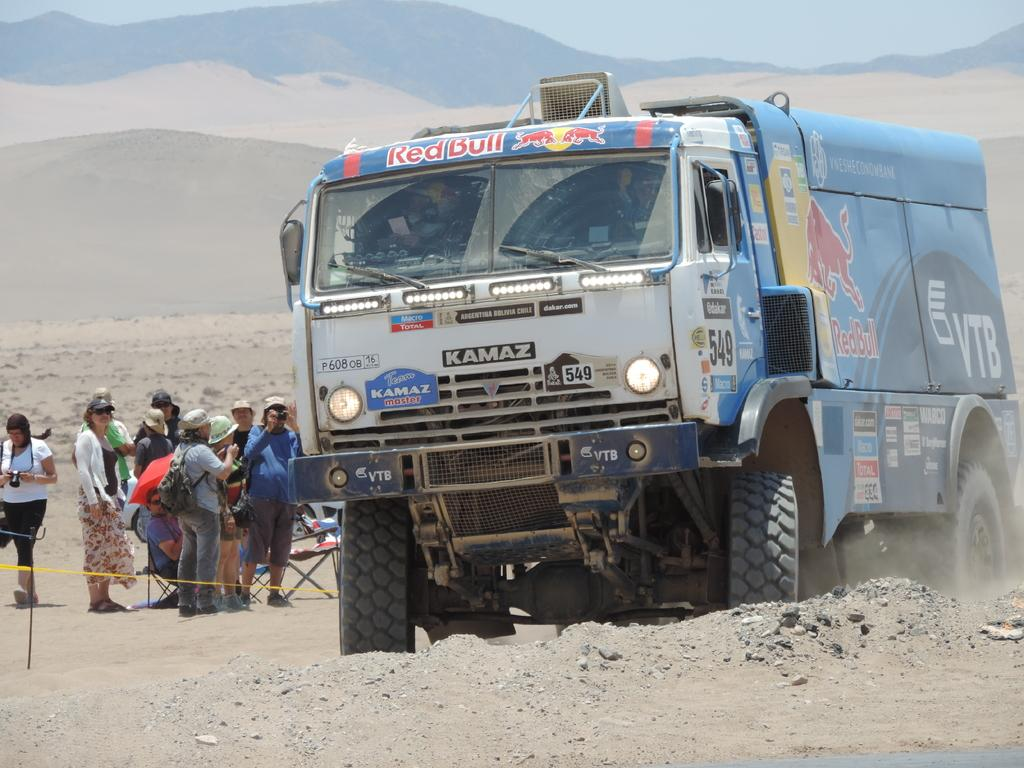What is the main subject in the image? There is a vehicle in the image. What else can be seen in the image besides the vehicle? There is a group of people standing in the image. What is visible in the background of the image? Mountains are visible in the background of the image. What is visible at the top of the image? The sky is visible at the top of the image. What type of terrain is present at the bottom of the image? There is sand at the bottom of the image. How many lizards can be seen crawling on the vehicle in the image? There are no lizards present in the image; it only features a vehicle, a group of people, mountains, sky, and sand. What type of crow is perched on the roof of the vehicle in the image? There is no crow present on the vehicle or in the image. 